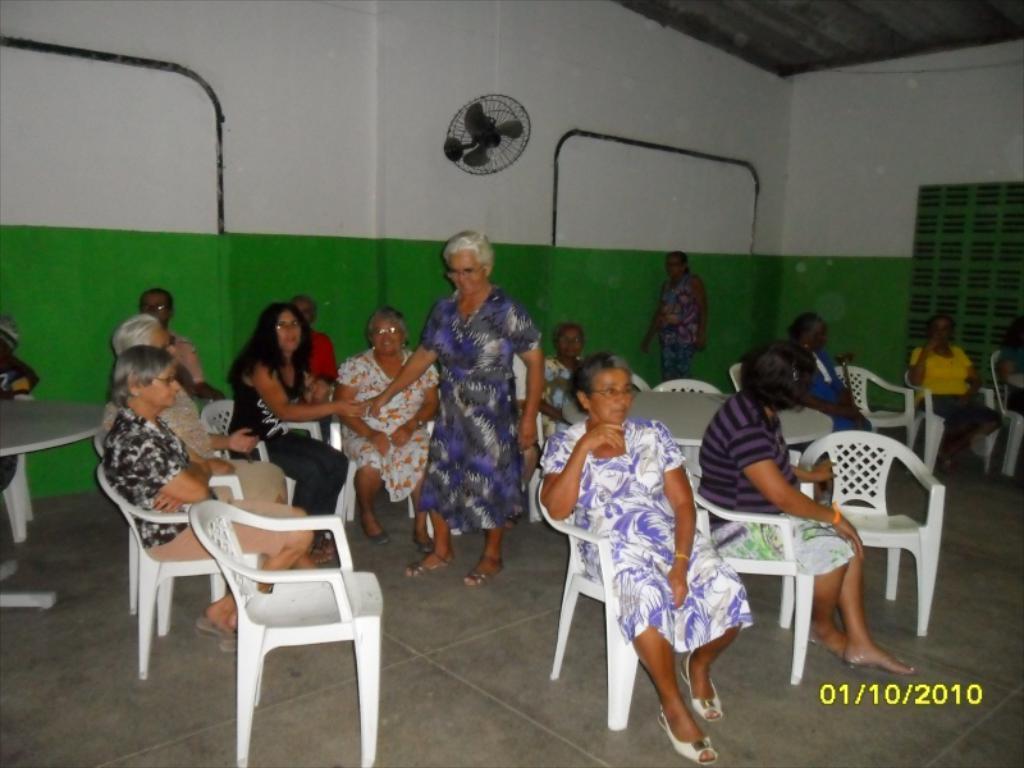Please provide a concise description of this image. There are few women sitting on the hair and 2 women are standing. On the wall there is a table fan and here there is a window. 